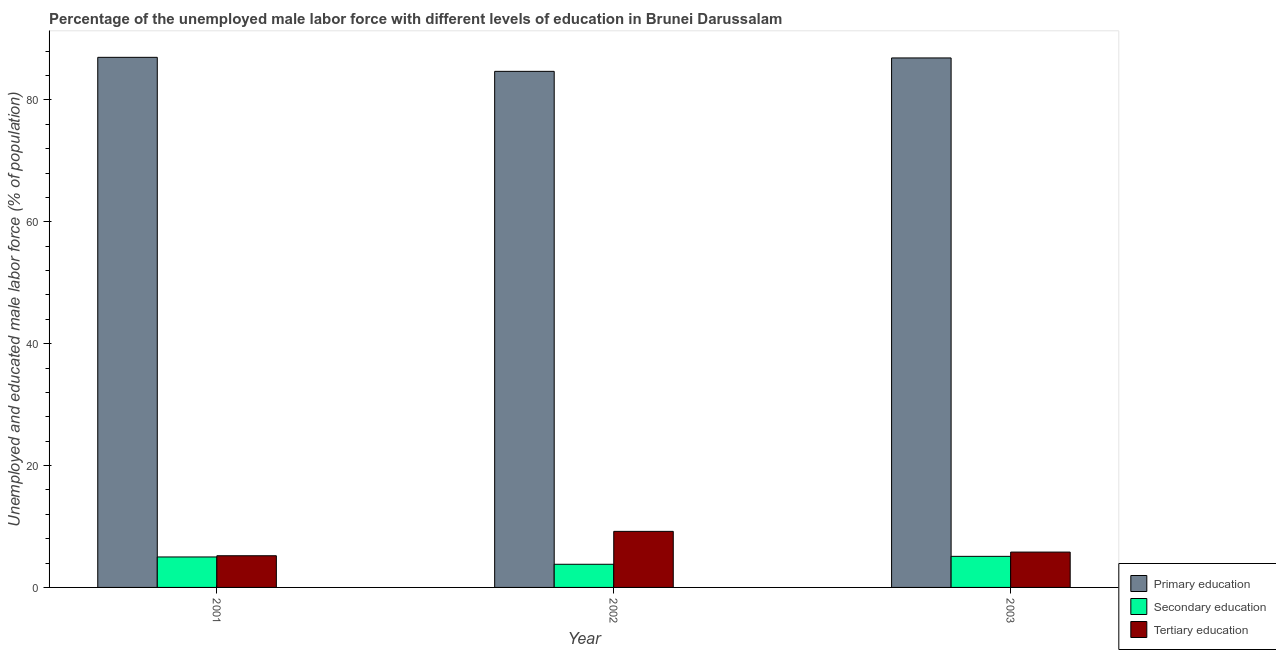How many different coloured bars are there?
Offer a terse response. 3. How many bars are there on the 2nd tick from the left?
Make the answer very short. 3. What is the percentage of male labor force who received primary education in 2001?
Ensure brevity in your answer.  87. Across all years, what is the maximum percentage of male labor force who received primary education?
Provide a succinct answer. 87. Across all years, what is the minimum percentage of male labor force who received secondary education?
Offer a terse response. 3.8. In which year was the percentage of male labor force who received tertiary education maximum?
Give a very brief answer. 2002. In which year was the percentage of male labor force who received tertiary education minimum?
Your answer should be very brief. 2001. What is the total percentage of male labor force who received primary education in the graph?
Give a very brief answer. 258.6. What is the difference between the percentage of male labor force who received tertiary education in 2002 and that in 2003?
Your answer should be very brief. 3.4. What is the difference between the percentage of male labor force who received secondary education in 2003 and the percentage of male labor force who received primary education in 2001?
Your response must be concise. 0.1. What is the average percentage of male labor force who received secondary education per year?
Offer a terse response. 4.63. In the year 2002, what is the difference between the percentage of male labor force who received tertiary education and percentage of male labor force who received secondary education?
Offer a very short reply. 0. What is the ratio of the percentage of male labor force who received primary education in 2002 to that in 2003?
Give a very brief answer. 0.97. Is the percentage of male labor force who received primary education in 2001 less than that in 2003?
Your answer should be compact. No. What is the difference between the highest and the second highest percentage of male labor force who received tertiary education?
Offer a very short reply. 3.4. What is the difference between the highest and the lowest percentage of male labor force who received secondary education?
Offer a terse response. 1.3. In how many years, is the percentage of male labor force who received primary education greater than the average percentage of male labor force who received primary education taken over all years?
Your answer should be compact. 2. What does the 3rd bar from the left in 2003 represents?
Provide a succinct answer. Tertiary education. What does the 1st bar from the right in 2001 represents?
Ensure brevity in your answer.  Tertiary education. Is it the case that in every year, the sum of the percentage of male labor force who received primary education and percentage of male labor force who received secondary education is greater than the percentage of male labor force who received tertiary education?
Your response must be concise. Yes. Are all the bars in the graph horizontal?
Keep it short and to the point. No. How many years are there in the graph?
Make the answer very short. 3. Are the values on the major ticks of Y-axis written in scientific E-notation?
Offer a terse response. No. Does the graph contain any zero values?
Your answer should be compact. No. Where does the legend appear in the graph?
Provide a succinct answer. Bottom right. How many legend labels are there?
Provide a short and direct response. 3. What is the title of the graph?
Offer a very short reply. Percentage of the unemployed male labor force with different levels of education in Brunei Darussalam. Does "Textiles and clothing" appear as one of the legend labels in the graph?
Offer a very short reply. No. What is the label or title of the Y-axis?
Your response must be concise. Unemployed and educated male labor force (% of population). What is the Unemployed and educated male labor force (% of population) in Tertiary education in 2001?
Your response must be concise. 5.2. What is the Unemployed and educated male labor force (% of population) in Primary education in 2002?
Your answer should be very brief. 84.7. What is the Unemployed and educated male labor force (% of population) in Secondary education in 2002?
Keep it short and to the point. 3.8. What is the Unemployed and educated male labor force (% of population) of Tertiary education in 2002?
Keep it short and to the point. 9.2. What is the Unemployed and educated male labor force (% of population) of Primary education in 2003?
Provide a succinct answer. 86.9. What is the Unemployed and educated male labor force (% of population) in Secondary education in 2003?
Provide a succinct answer. 5.1. What is the Unemployed and educated male labor force (% of population) in Tertiary education in 2003?
Offer a terse response. 5.8. Across all years, what is the maximum Unemployed and educated male labor force (% of population) of Primary education?
Ensure brevity in your answer.  87. Across all years, what is the maximum Unemployed and educated male labor force (% of population) in Secondary education?
Offer a terse response. 5.1. Across all years, what is the maximum Unemployed and educated male labor force (% of population) in Tertiary education?
Make the answer very short. 9.2. Across all years, what is the minimum Unemployed and educated male labor force (% of population) in Primary education?
Make the answer very short. 84.7. Across all years, what is the minimum Unemployed and educated male labor force (% of population) of Secondary education?
Ensure brevity in your answer.  3.8. Across all years, what is the minimum Unemployed and educated male labor force (% of population) of Tertiary education?
Ensure brevity in your answer.  5.2. What is the total Unemployed and educated male labor force (% of population) of Primary education in the graph?
Offer a terse response. 258.6. What is the total Unemployed and educated male labor force (% of population) in Secondary education in the graph?
Provide a short and direct response. 13.9. What is the total Unemployed and educated male labor force (% of population) of Tertiary education in the graph?
Your response must be concise. 20.2. What is the difference between the Unemployed and educated male labor force (% of population) of Primary education in 2001 and that in 2002?
Your response must be concise. 2.3. What is the difference between the Unemployed and educated male labor force (% of population) of Secondary education in 2001 and that in 2002?
Your answer should be compact. 1.2. What is the difference between the Unemployed and educated male labor force (% of population) in Primary education in 2001 and that in 2003?
Keep it short and to the point. 0.1. What is the difference between the Unemployed and educated male labor force (% of population) in Secondary education in 2001 and that in 2003?
Offer a terse response. -0.1. What is the difference between the Unemployed and educated male labor force (% of population) of Secondary education in 2002 and that in 2003?
Provide a succinct answer. -1.3. What is the difference between the Unemployed and educated male labor force (% of population) of Tertiary education in 2002 and that in 2003?
Provide a short and direct response. 3.4. What is the difference between the Unemployed and educated male labor force (% of population) of Primary education in 2001 and the Unemployed and educated male labor force (% of population) of Secondary education in 2002?
Your response must be concise. 83.2. What is the difference between the Unemployed and educated male labor force (% of population) of Primary education in 2001 and the Unemployed and educated male labor force (% of population) of Tertiary education in 2002?
Provide a short and direct response. 77.8. What is the difference between the Unemployed and educated male labor force (% of population) of Primary education in 2001 and the Unemployed and educated male labor force (% of population) of Secondary education in 2003?
Make the answer very short. 81.9. What is the difference between the Unemployed and educated male labor force (% of population) in Primary education in 2001 and the Unemployed and educated male labor force (% of population) in Tertiary education in 2003?
Provide a succinct answer. 81.2. What is the difference between the Unemployed and educated male labor force (% of population) in Primary education in 2002 and the Unemployed and educated male labor force (% of population) in Secondary education in 2003?
Ensure brevity in your answer.  79.6. What is the difference between the Unemployed and educated male labor force (% of population) of Primary education in 2002 and the Unemployed and educated male labor force (% of population) of Tertiary education in 2003?
Offer a very short reply. 78.9. What is the average Unemployed and educated male labor force (% of population) in Primary education per year?
Provide a short and direct response. 86.2. What is the average Unemployed and educated male labor force (% of population) in Secondary education per year?
Give a very brief answer. 4.63. What is the average Unemployed and educated male labor force (% of population) of Tertiary education per year?
Offer a very short reply. 6.73. In the year 2001, what is the difference between the Unemployed and educated male labor force (% of population) of Primary education and Unemployed and educated male labor force (% of population) of Secondary education?
Your response must be concise. 82. In the year 2001, what is the difference between the Unemployed and educated male labor force (% of population) of Primary education and Unemployed and educated male labor force (% of population) of Tertiary education?
Offer a terse response. 81.8. In the year 2001, what is the difference between the Unemployed and educated male labor force (% of population) in Secondary education and Unemployed and educated male labor force (% of population) in Tertiary education?
Give a very brief answer. -0.2. In the year 2002, what is the difference between the Unemployed and educated male labor force (% of population) of Primary education and Unemployed and educated male labor force (% of population) of Secondary education?
Keep it short and to the point. 80.9. In the year 2002, what is the difference between the Unemployed and educated male labor force (% of population) in Primary education and Unemployed and educated male labor force (% of population) in Tertiary education?
Give a very brief answer. 75.5. In the year 2003, what is the difference between the Unemployed and educated male labor force (% of population) in Primary education and Unemployed and educated male labor force (% of population) in Secondary education?
Provide a short and direct response. 81.8. In the year 2003, what is the difference between the Unemployed and educated male labor force (% of population) in Primary education and Unemployed and educated male labor force (% of population) in Tertiary education?
Offer a terse response. 81.1. What is the ratio of the Unemployed and educated male labor force (% of population) of Primary education in 2001 to that in 2002?
Provide a succinct answer. 1.03. What is the ratio of the Unemployed and educated male labor force (% of population) in Secondary education in 2001 to that in 2002?
Your answer should be compact. 1.32. What is the ratio of the Unemployed and educated male labor force (% of population) in Tertiary education in 2001 to that in 2002?
Your response must be concise. 0.57. What is the ratio of the Unemployed and educated male labor force (% of population) of Primary education in 2001 to that in 2003?
Offer a very short reply. 1. What is the ratio of the Unemployed and educated male labor force (% of population) in Secondary education in 2001 to that in 2003?
Give a very brief answer. 0.98. What is the ratio of the Unemployed and educated male labor force (% of population) of Tertiary education in 2001 to that in 2003?
Give a very brief answer. 0.9. What is the ratio of the Unemployed and educated male labor force (% of population) in Primary education in 2002 to that in 2003?
Make the answer very short. 0.97. What is the ratio of the Unemployed and educated male labor force (% of population) in Secondary education in 2002 to that in 2003?
Keep it short and to the point. 0.75. What is the ratio of the Unemployed and educated male labor force (% of population) in Tertiary education in 2002 to that in 2003?
Offer a terse response. 1.59. What is the difference between the highest and the second highest Unemployed and educated male labor force (% of population) in Secondary education?
Provide a short and direct response. 0.1. What is the difference between the highest and the lowest Unemployed and educated male labor force (% of population) of Primary education?
Offer a very short reply. 2.3. What is the difference between the highest and the lowest Unemployed and educated male labor force (% of population) of Secondary education?
Your response must be concise. 1.3. 